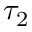Convert formula to latex. <formula><loc_0><loc_0><loc_500><loc_500>\tau _ { 2 }</formula> 